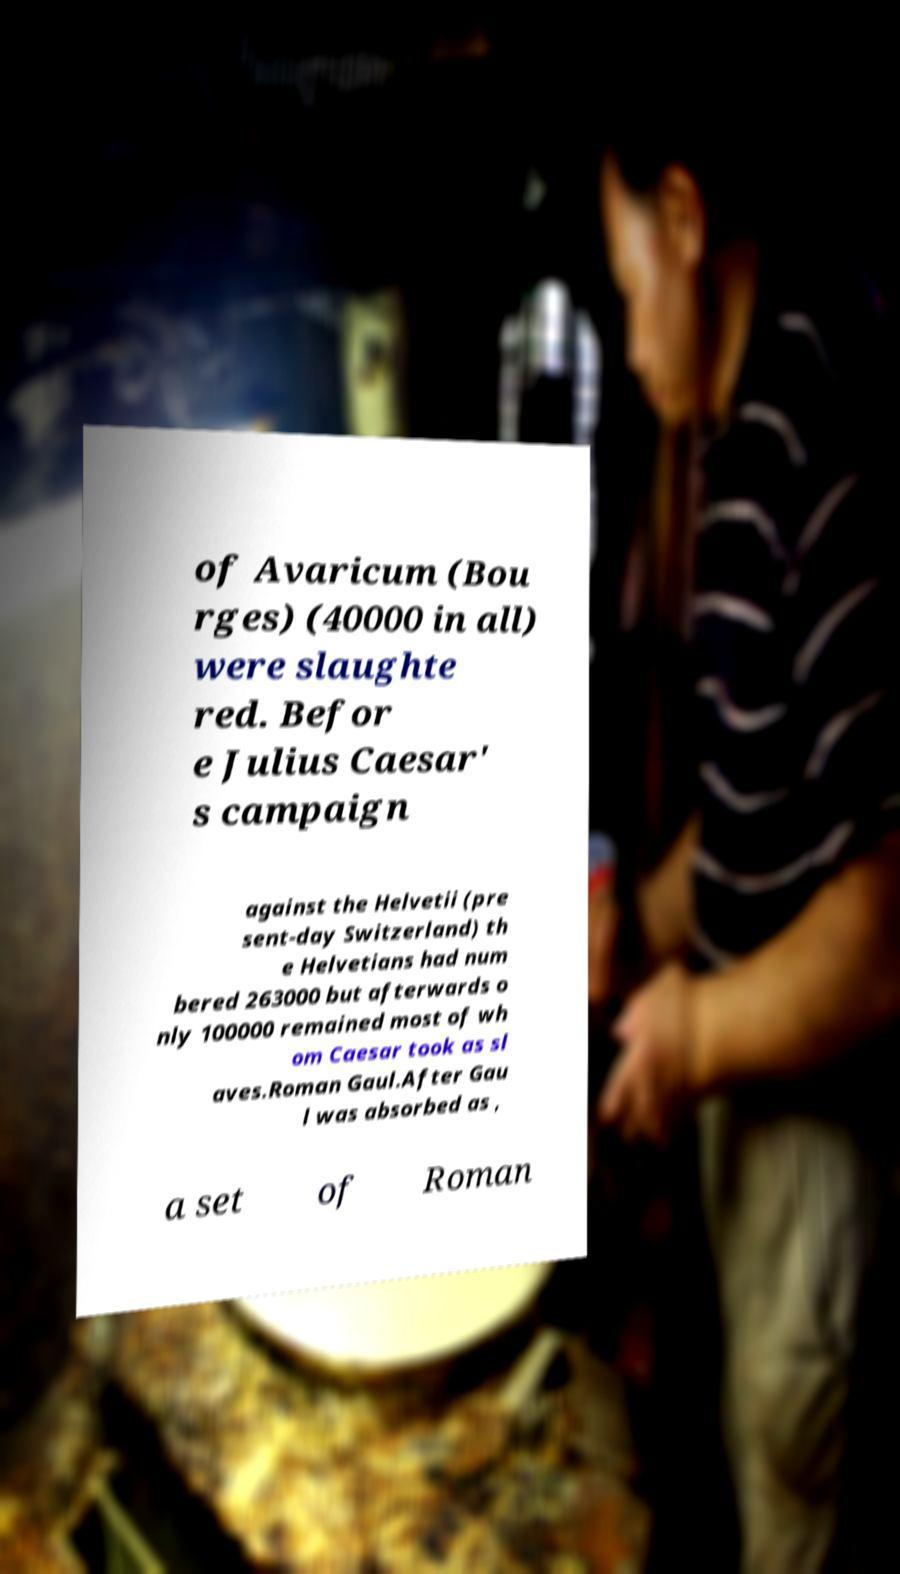Could you extract and type out the text from this image? of Avaricum (Bou rges) (40000 in all) were slaughte red. Befor e Julius Caesar' s campaign against the Helvetii (pre sent-day Switzerland) th e Helvetians had num bered 263000 but afterwards o nly 100000 remained most of wh om Caesar took as sl aves.Roman Gaul.After Gau l was absorbed as , a set of Roman 